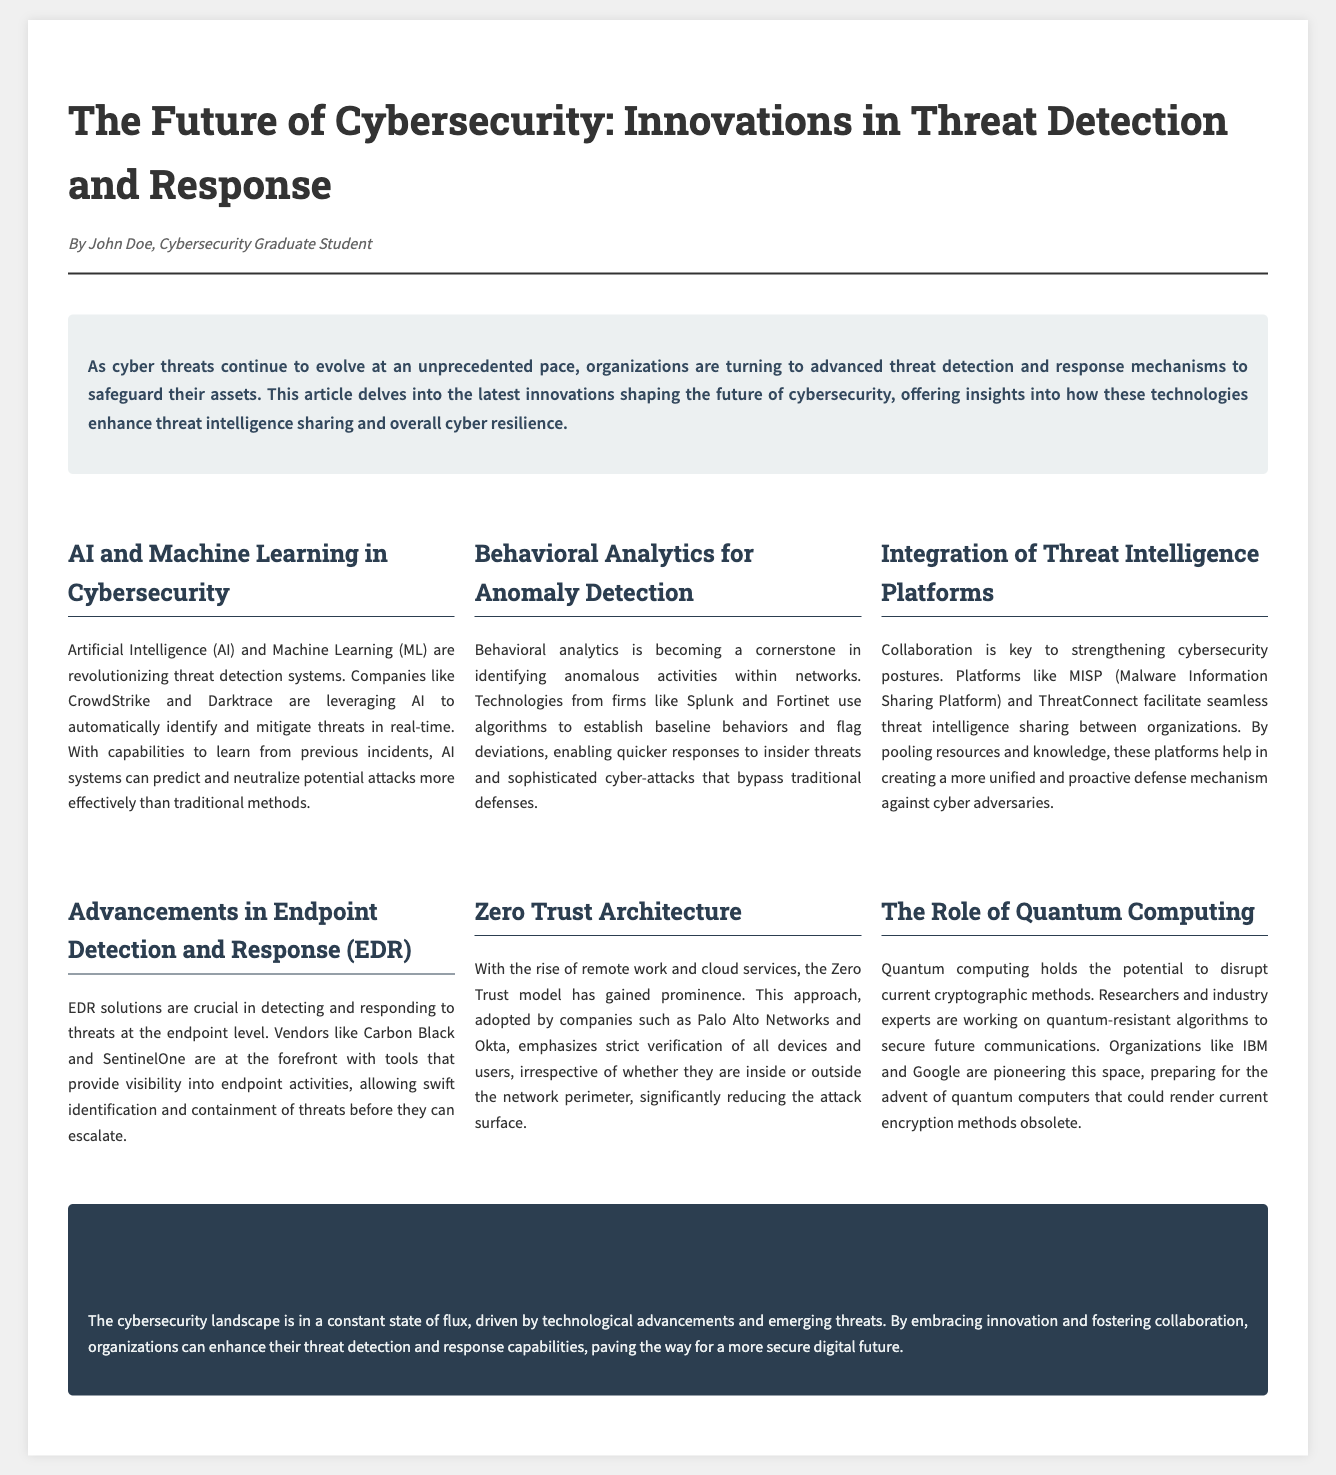What is the title of the article? The title of the article is presented prominently at the top of the document.
Answer: The Future of Cybersecurity: Innovations in Threat Detection and Response Who is the author of the article? The author is credited in the byline under the title of the article.
Answer: John Doe What technology is highlighted for real-time threat identification? The document discusses specific technologies used in threat detection.
Answer: AI and Machine Learning Which platforms facilitate threat intelligence sharing? The article mentions specific platforms that assist in collaboration.
Answer: MISP and ThreatConnect What model emphasizes strict user verification? The document outlines security approaches within cybersecurity.
Answer: Zero Trust Architecture How do behavioral analytics contribute to security? The section on behavioral analytics explains its purpose in cybersecurity.
Answer: Anomaly Detection What is one challenge posed by quantum computing? The article identifies potential threats to current security practices.
Answer: Disrupt cryptographic methods Which companies are mentioned as leaders in EDR solutions? The document provides information on specific vendors in the EDR space.
Answer: Carbon Black and SentinelOne What is a benefit of AI systems in cybersecurity? The text describes advantages of AI technologies in threat management.
Answer: Predict and neutralize potential attacks 